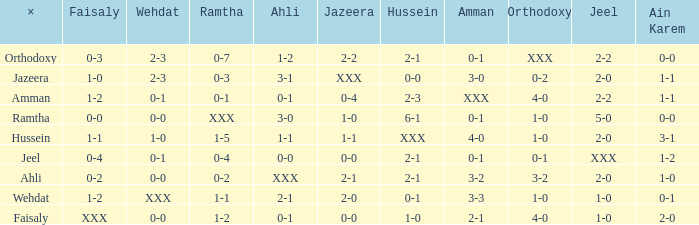What is faisaly when wehdat is xxx? 1-2. Would you be able to parse every entry in this table? {'header': ['×', 'Faisaly', 'Wehdat', 'Ramtha', 'Ahli', 'Jazeera', 'Hussein', 'Amman', 'Orthodoxy', 'Jeel', 'Ain Karem'], 'rows': [['Orthodoxy', '0-3', '2-3', '0-7', '1-2', '2-2', '2-1', '0-1', 'XXX', '2-2', '0-0'], ['Jazeera', '1-0', '2-3', '0-3', '3-1', 'XXX', '0-0', '3-0', '0-2', '2-0', '1-1'], ['Amman', '1-2', '0-1', '0-1', '0-1', '0-4', '2-3', 'XXX', '4-0', '2-2', '1-1'], ['Ramtha', '0-0', '0-0', 'XXX', '3-0', '1-0', '6-1', '0-1', '1-0', '5-0', '0-0'], ['Hussein', '1-1', '1-0', '1-5', '1-1', '1-1', 'XXX', '4-0', '1-0', '2-0', '3-1'], ['Jeel', '0-4', '0-1', '0-4', '0-0', '0-0', '2-1', '0-1', '0-1', 'XXX', '1-2'], ['Ahli', '0-2', '0-0', '0-2', 'XXX', '2-1', '2-1', '3-2', '3-2', '2-0', '1-0'], ['Wehdat', '1-2', 'XXX', '1-1', '2-1', '2-0', '0-1', '3-3', '1-0', '1-0', '0-1'], ['Faisaly', 'XXX', '0-0', '1-2', '0-1', '0-0', '1-0', '2-1', '4-0', '1-0', '2-0']]} 